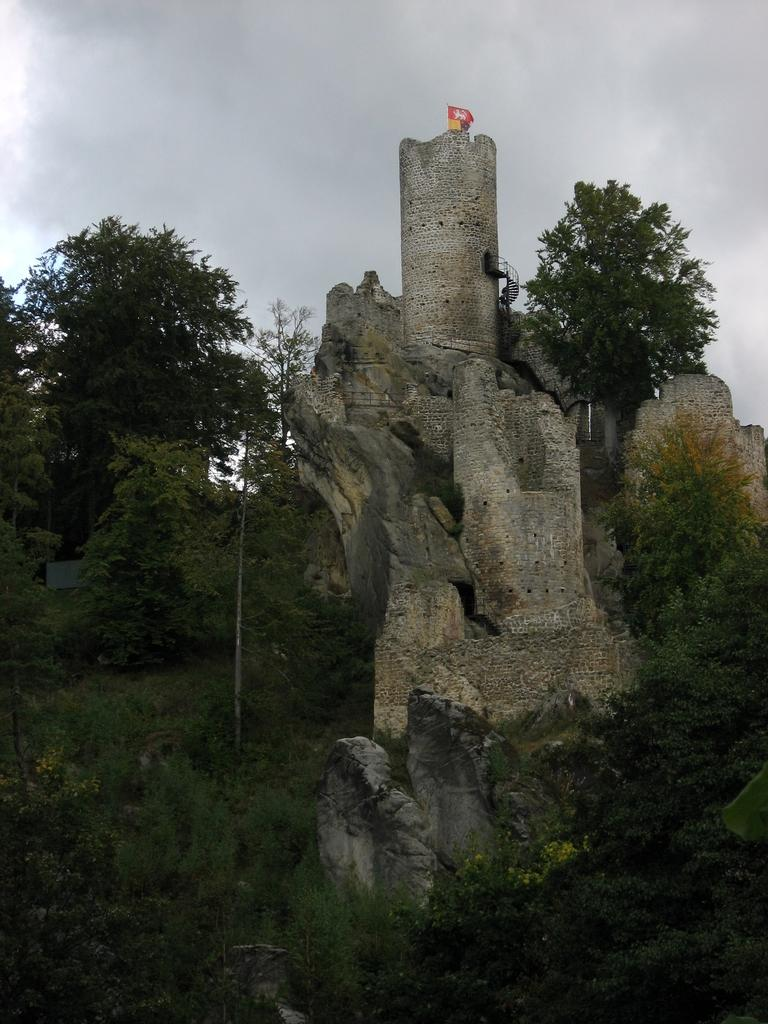What type of natural elements can be seen in the image? There are trees in the image. What other objects can be seen in the image? There are rocks in the image. What type of structure is present in the image? There is a fort in the image. What type of oranges are being used to decorate the fort in the image? There are no oranges present in the image; the focus is on the trees, rocks, and fort. 